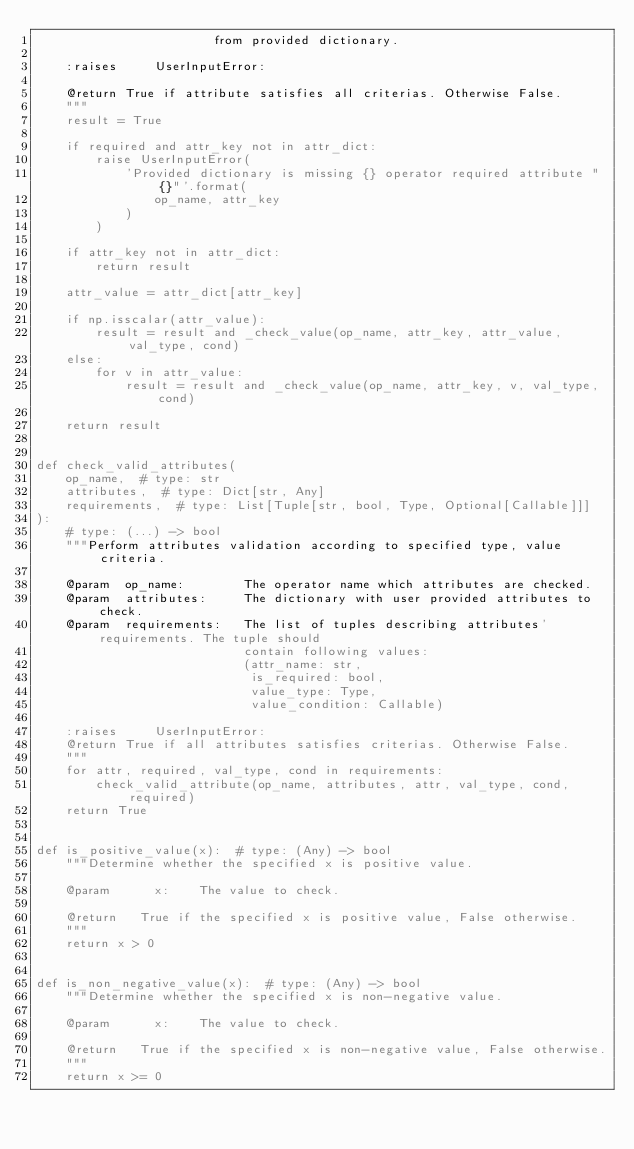<code> <loc_0><loc_0><loc_500><loc_500><_Python_>                        from provided dictionary.

    :raises     UserInputError:

    @return True if attribute satisfies all criterias. Otherwise False.
    """
    result = True

    if required and attr_key not in attr_dict:
        raise UserInputError(
            'Provided dictionary is missing {} operator required attribute "{}"'.format(
                op_name, attr_key
            )
        )

    if attr_key not in attr_dict:
        return result

    attr_value = attr_dict[attr_key]

    if np.isscalar(attr_value):
        result = result and _check_value(op_name, attr_key, attr_value, val_type, cond)
    else:
        for v in attr_value:
            result = result and _check_value(op_name, attr_key, v, val_type, cond)

    return result


def check_valid_attributes(
    op_name,  # type: str
    attributes,  # type: Dict[str, Any]
    requirements,  # type: List[Tuple[str, bool, Type, Optional[Callable]]]
):
    # type: (...) -> bool
    """Perform attributes validation according to specified type, value criteria.

    @param  op_name:        The operator name which attributes are checked.
    @param  attributes:     The dictionary with user provided attributes to check.
    @param  requirements:   The list of tuples describing attributes' requirements. The tuple should
                            contain following values:
                            (attr_name: str,
                             is_required: bool,
                             value_type: Type,
                             value_condition: Callable)

    :raises     UserInputError:
    @return True if all attributes satisfies criterias. Otherwise False.
    """
    for attr, required, val_type, cond in requirements:
        check_valid_attribute(op_name, attributes, attr, val_type, cond, required)
    return True


def is_positive_value(x):  # type: (Any) -> bool
    """Determine whether the specified x is positive value.

    @param      x:    The value to check.

    @return   True if the specified x is positive value, False otherwise.
    """
    return x > 0


def is_non_negative_value(x):  # type: (Any) -> bool
    """Determine whether the specified x is non-negative value.

    @param      x:    The value to check.

    @return   True if the specified x is non-negative value, False otherwise.
    """
    return x >= 0
</code> 